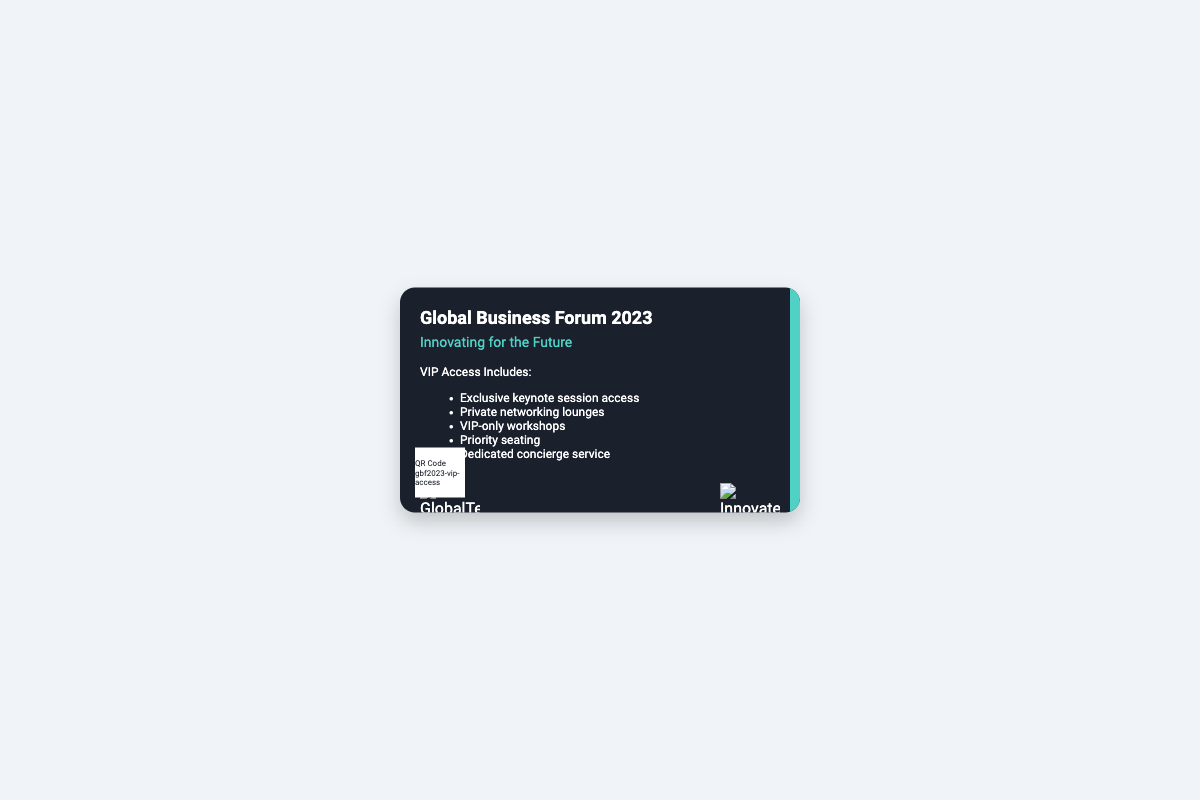What is the name of the event? The name of the event is displayed prominently at the top of the card.
Answer: Global Business Forum 2023 What is the event theme? The event theme is presented directly below the event name.
Answer: Innovating for the Future What type of access does the pass provide? The pass is labeled with the type of access patrons receive.
Answer: VIP Access List one benefit of the VIP access. The benefits of VIP access are outlined in a list format on the card.
Answer: Exclusive keynote session access How many companies' logos are displayed on the card? The logos are visible at the bottom of the card which represent the sponsors.
Answer: 2 What color is the accent line? The accent line color is specified within the card design details.
Answer: Teal Where is the QR code located on the card? The position of the QR code is specifically described in the style of the card.
Answer: Bottom left What is the primary background color of the card? The primary background color for the card is indicated in the style section of the code.
Answer: Dark gray 